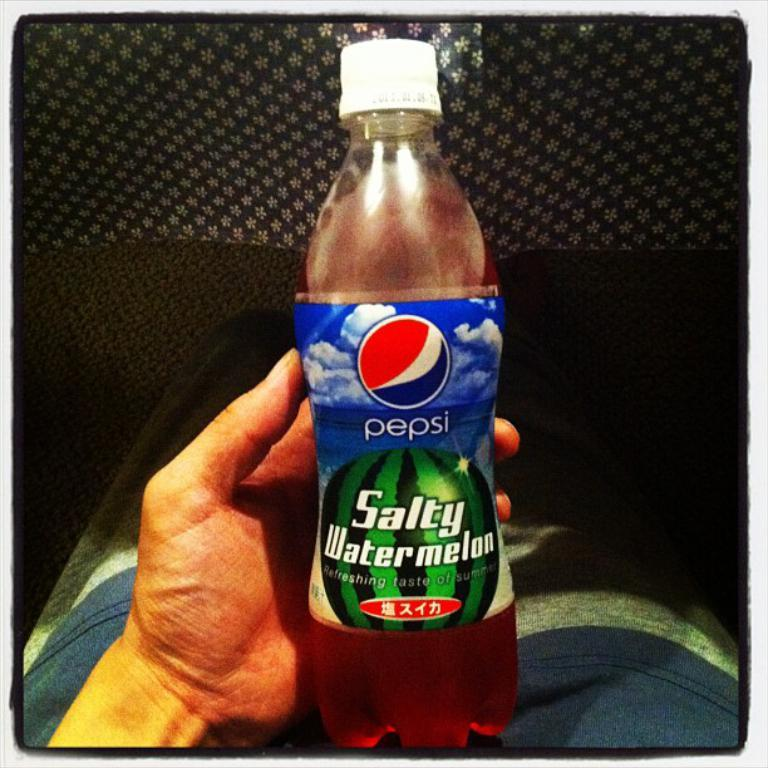What is the main subject of the image? There is a person in the image. What is the person holding in the image? The person is holding a bottle. What is written on the bottle? The bottle has the words "Pepsi Salty Watermelon" written on it. What type of stone can be seen attached to the stem of the bottle in the image? There is no stone or stem present on the bottle in the image. 